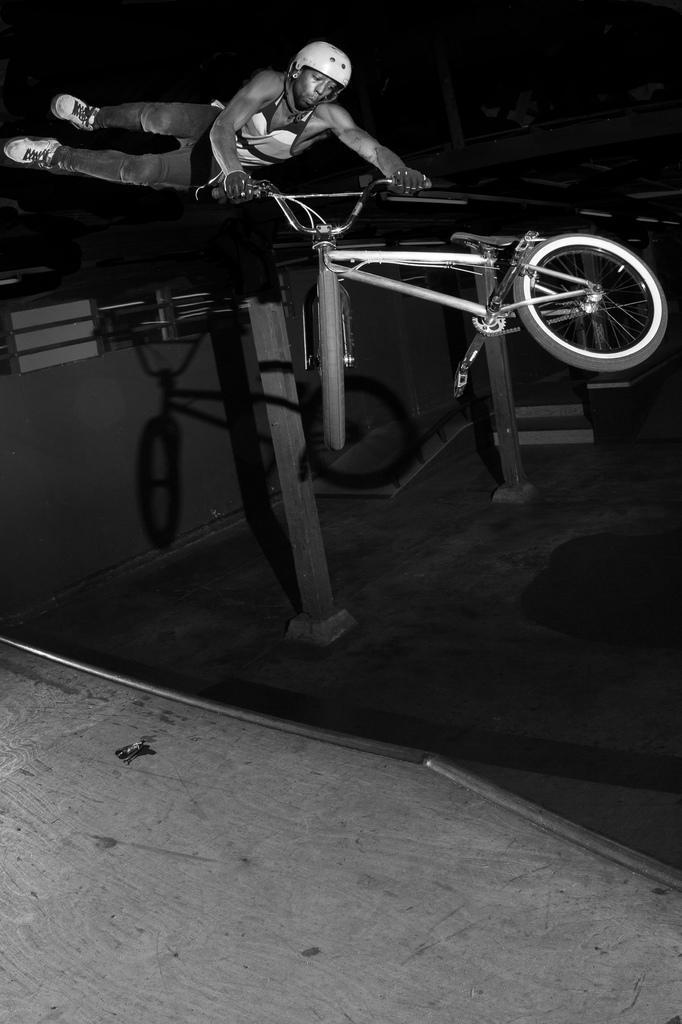Please provide a concise description of this image. This image is a black and white image. This image is taken outdoors. At the bottom of the image there is a floor. In this image the background is dark and there is a railing. In the middle of the image a man is performing stunts with a bicycle. There are two iron rods. 